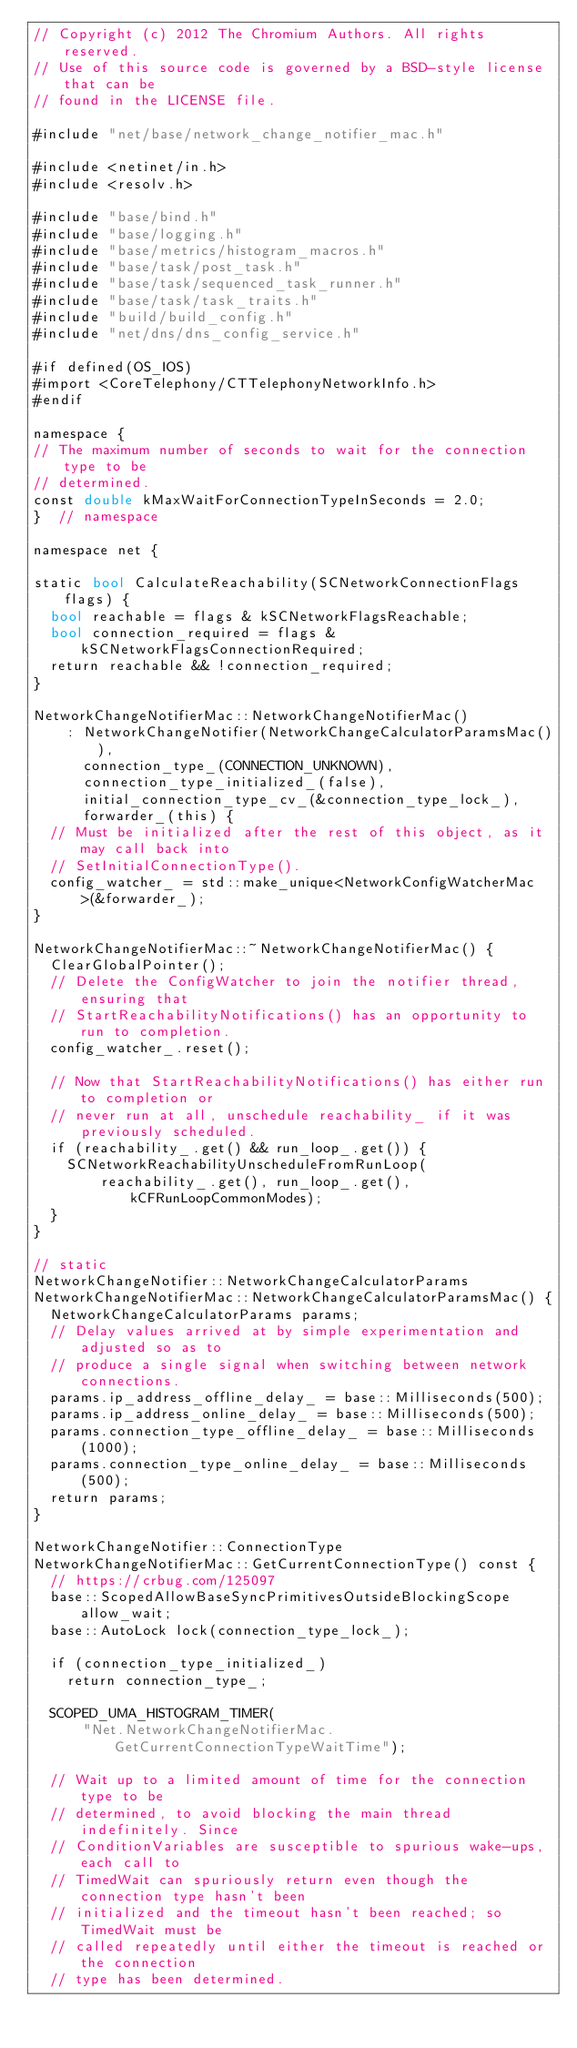<code> <loc_0><loc_0><loc_500><loc_500><_ObjectiveC_>// Copyright (c) 2012 The Chromium Authors. All rights reserved.
// Use of this source code is governed by a BSD-style license that can be
// found in the LICENSE file.

#include "net/base/network_change_notifier_mac.h"

#include <netinet/in.h>
#include <resolv.h>

#include "base/bind.h"
#include "base/logging.h"
#include "base/metrics/histogram_macros.h"
#include "base/task/post_task.h"
#include "base/task/sequenced_task_runner.h"
#include "base/task/task_traits.h"
#include "build/build_config.h"
#include "net/dns/dns_config_service.h"

#if defined(OS_IOS)
#import <CoreTelephony/CTTelephonyNetworkInfo.h>
#endif

namespace {
// The maximum number of seconds to wait for the connection type to be
// determined.
const double kMaxWaitForConnectionTypeInSeconds = 2.0;
}  // namespace

namespace net {

static bool CalculateReachability(SCNetworkConnectionFlags flags) {
  bool reachable = flags & kSCNetworkFlagsReachable;
  bool connection_required = flags & kSCNetworkFlagsConnectionRequired;
  return reachable && !connection_required;
}

NetworkChangeNotifierMac::NetworkChangeNotifierMac()
    : NetworkChangeNotifier(NetworkChangeCalculatorParamsMac()),
      connection_type_(CONNECTION_UNKNOWN),
      connection_type_initialized_(false),
      initial_connection_type_cv_(&connection_type_lock_),
      forwarder_(this) {
  // Must be initialized after the rest of this object, as it may call back into
  // SetInitialConnectionType().
  config_watcher_ = std::make_unique<NetworkConfigWatcherMac>(&forwarder_);
}

NetworkChangeNotifierMac::~NetworkChangeNotifierMac() {
  ClearGlobalPointer();
  // Delete the ConfigWatcher to join the notifier thread, ensuring that
  // StartReachabilityNotifications() has an opportunity to run to completion.
  config_watcher_.reset();

  // Now that StartReachabilityNotifications() has either run to completion or
  // never run at all, unschedule reachability_ if it was previously scheduled.
  if (reachability_.get() && run_loop_.get()) {
    SCNetworkReachabilityUnscheduleFromRunLoop(
        reachability_.get(), run_loop_.get(), kCFRunLoopCommonModes);
  }
}

// static
NetworkChangeNotifier::NetworkChangeCalculatorParams
NetworkChangeNotifierMac::NetworkChangeCalculatorParamsMac() {
  NetworkChangeCalculatorParams params;
  // Delay values arrived at by simple experimentation and adjusted so as to
  // produce a single signal when switching between network connections.
  params.ip_address_offline_delay_ = base::Milliseconds(500);
  params.ip_address_online_delay_ = base::Milliseconds(500);
  params.connection_type_offline_delay_ = base::Milliseconds(1000);
  params.connection_type_online_delay_ = base::Milliseconds(500);
  return params;
}

NetworkChangeNotifier::ConnectionType
NetworkChangeNotifierMac::GetCurrentConnectionType() const {
  // https://crbug.com/125097
  base::ScopedAllowBaseSyncPrimitivesOutsideBlockingScope allow_wait;
  base::AutoLock lock(connection_type_lock_);

  if (connection_type_initialized_)
    return connection_type_;

  SCOPED_UMA_HISTOGRAM_TIMER(
      "Net.NetworkChangeNotifierMac.GetCurrentConnectionTypeWaitTime");

  // Wait up to a limited amount of time for the connection type to be
  // determined, to avoid blocking the main thread indefinitely. Since
  // ConditionVariables are susceptible to spurious wake-ups, each call to
  // TimedWait can spuriously return even though the connection type hasn't been
  // initialized and the timeout hasn't been reached; so TimedWait must be
  // called repeatedly until either the timeout is reached or the connection
  // type has been determined.</code> 